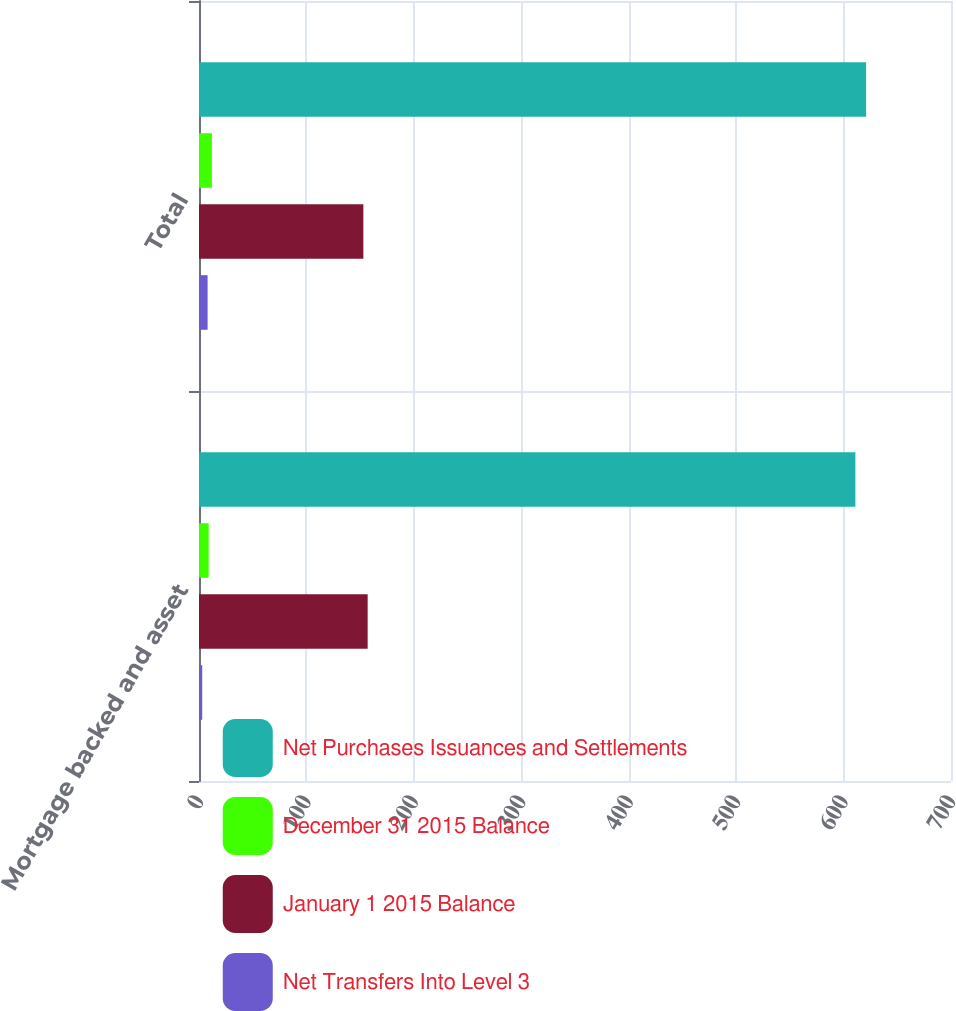Convert chart to OTSL. <chart><loc_0><loc_0><loc_500><loc_500><stacked_bar_chart><ecel><fcel>Mortgage backed and asset<fcel>Total<nl><fcel>Net Purchases Issuances and Settlements<fcel>611<fcel>621<nl><fcel>December 31 2015 Balance<fcel>9<fcel>12<nl><fcel>January 1 2015 Balance<fcel>157<fcel>153<nl><fcel>Net Transfers Into Level 3<fcel>3<fcel>8<nl></chart> 